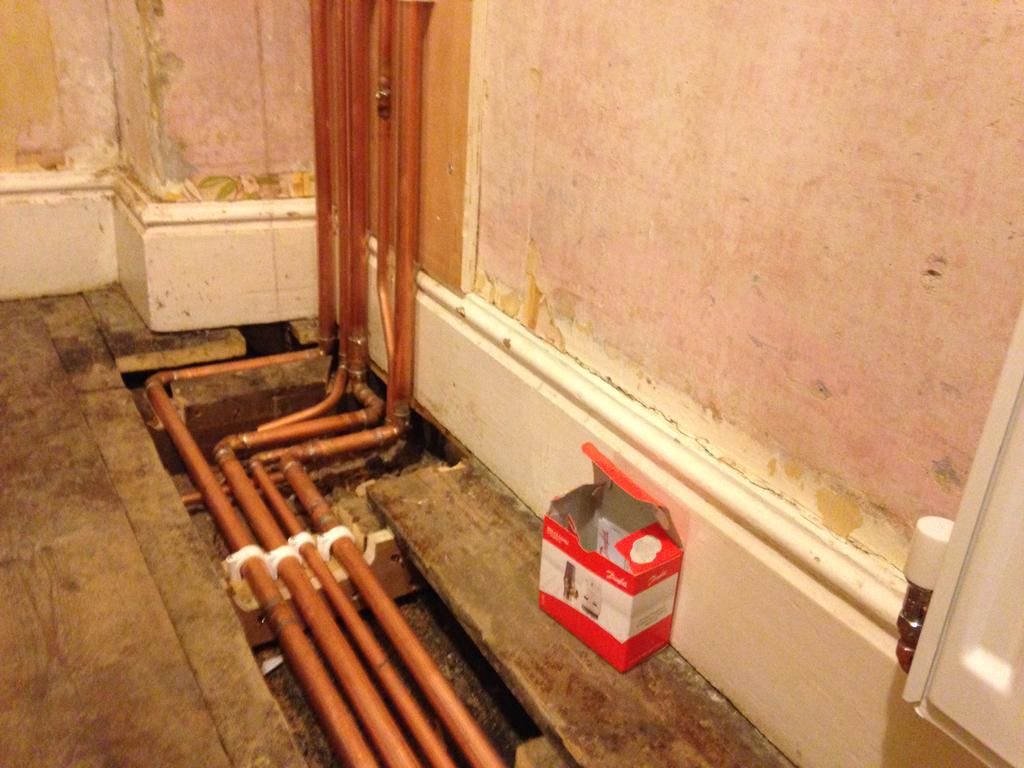What can be seen at the front of the image? There are pipes in the front of the image. What is located on the right side of the image? There is a box on the right side of the image. What type of structure is present in the image? There is a wall in the image. What is attached to the wall? There is a cupboard on the wall. What type of hair can be seen on the apple in the field in the image? There is no apple or field present in the image, and therefore no hair can be observed on an apple. 